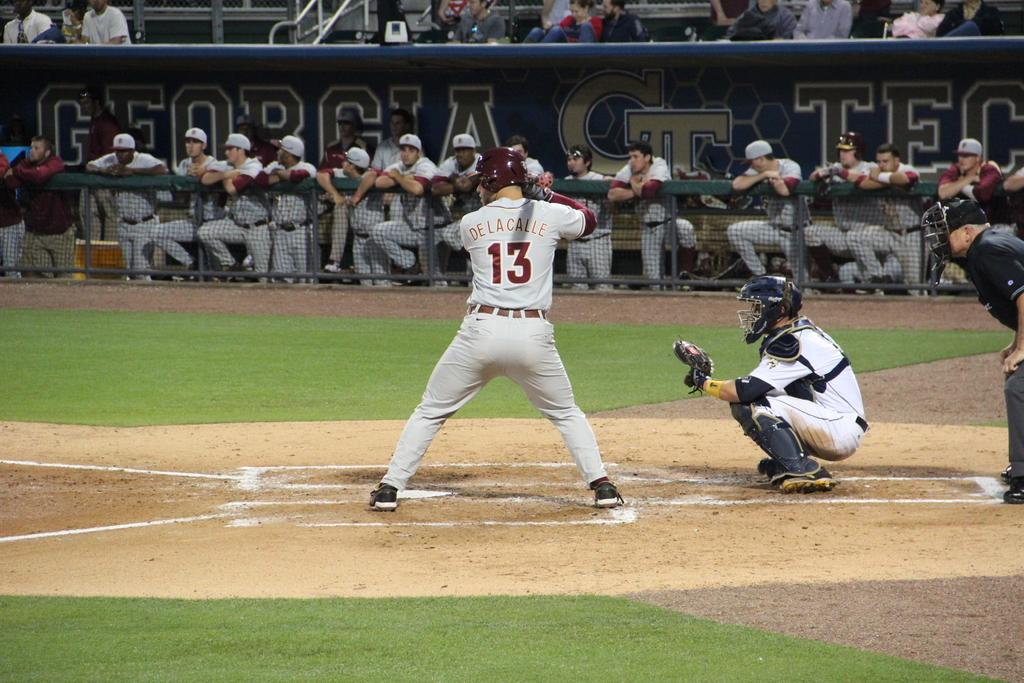<image>
Render a clear and concise summary of the photo. Baseball player standing ready to pitch wearing number 13. 